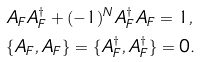Convert formula to latex. <formula><loc_0><loc_0><loc_500><loc_500>& A _ { F } A _ { F } ^ { \dagger } + ( - 1 ) ^ { N } A _ { F } ^ { \dagger } A _ { F } = 1 , \\ & \{ A _ { F } , A _ { F } \} = \{ A _ { F } ^ { \dagger } , A _ { F } ^ { \dagger } \} = 0 .</formula> 